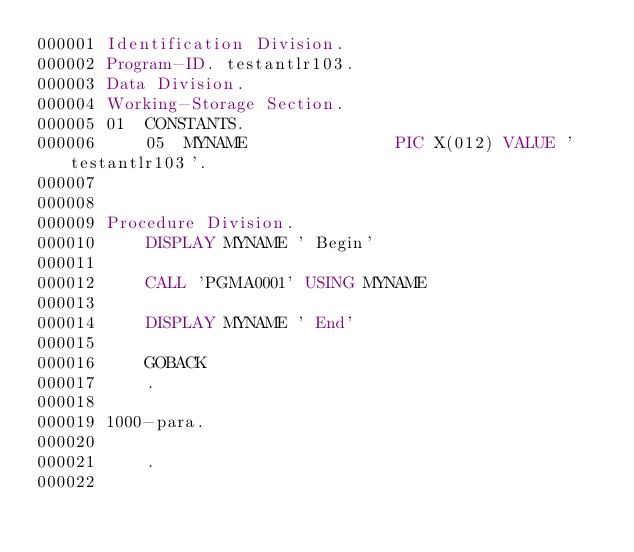<code> <loc_0><loc_0><loc_500><loc_500><_COBOL_>000001 Identification Division.
000002 Program-ID. testantlr103.
000003 Data Division.
000004 Working-Storage Section.
000005 01  CONSTANTS.
000006     05  MYNAME               PIC X(012) VALUE 'testantlr103'.
000007 
000008
000009 Procedure Division.
000010     DISPLAY MYNAME ' Begin'
000011     
000012     CALL 'PGMA0001' USING MYNAME
000013
000014     DISPLAY MYNAME ' End'
000015     
000016     GOBACK
000017     .
000018
000019 1000-para.
000020
000021     .
000022
</code> 